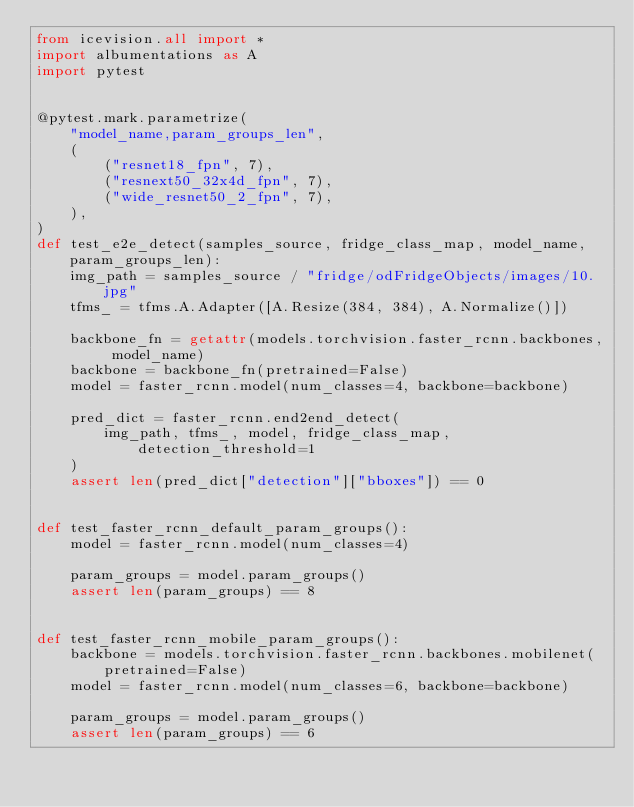<code> <loc_0><loc_0><loc_500><loc_500><_Python_>from icevision.all import *
import albumentations as A
import pytest


@pytest.mark.parametrize(
    "model_name,param_groups_len",
    (
        ("resnet18_fpn", 7),
        ("resnext50_32x4d_fpn", 7),
        ("wide_resnet50_2_fpn", 7),
    ),
)
def test_e2e_detect(samples_source, fridge_class_map, model_name, param_groups_len):
    img_path = samples_source / "fridge/odFridgeObjects/images/10.jpg"
    tfms_ = tfms.A.Adapter([A.Resize(384, 384), A.Normalize()])

    backbone_fn = getattr(models.torchvision.faster_rcnn.backbones, model_name)
    backbone = backbone_fn(pretrained=False)
    model = faster_rcnn.model(num_classes=4, backbone=backbone)

    pred_dict = faster_rcnn.end2end_detect(
        img_path, tfms_, model, fridge_class_map, detection_threshold=1
    )
    assert len(pred_dict["detection"]["bboxes"]) == 0


def test_faster_rcnn_default_param_groups():
    model = faster_rcnn.model(num_classes=4)

    param_groups = model.param_groups()
    assert len(param_groups) == 8


def test_faster_rcnn_mobile_param_groups():
    backbone = models.torchvision.faster_rcnn.backbones.mobilenet(pretrained=False)
    model = faster_rcnn.model(num_classes=6, backbone=backbone)

    param_groups = model.param_groups()
    assert len(param_groups) == 6
</code> 